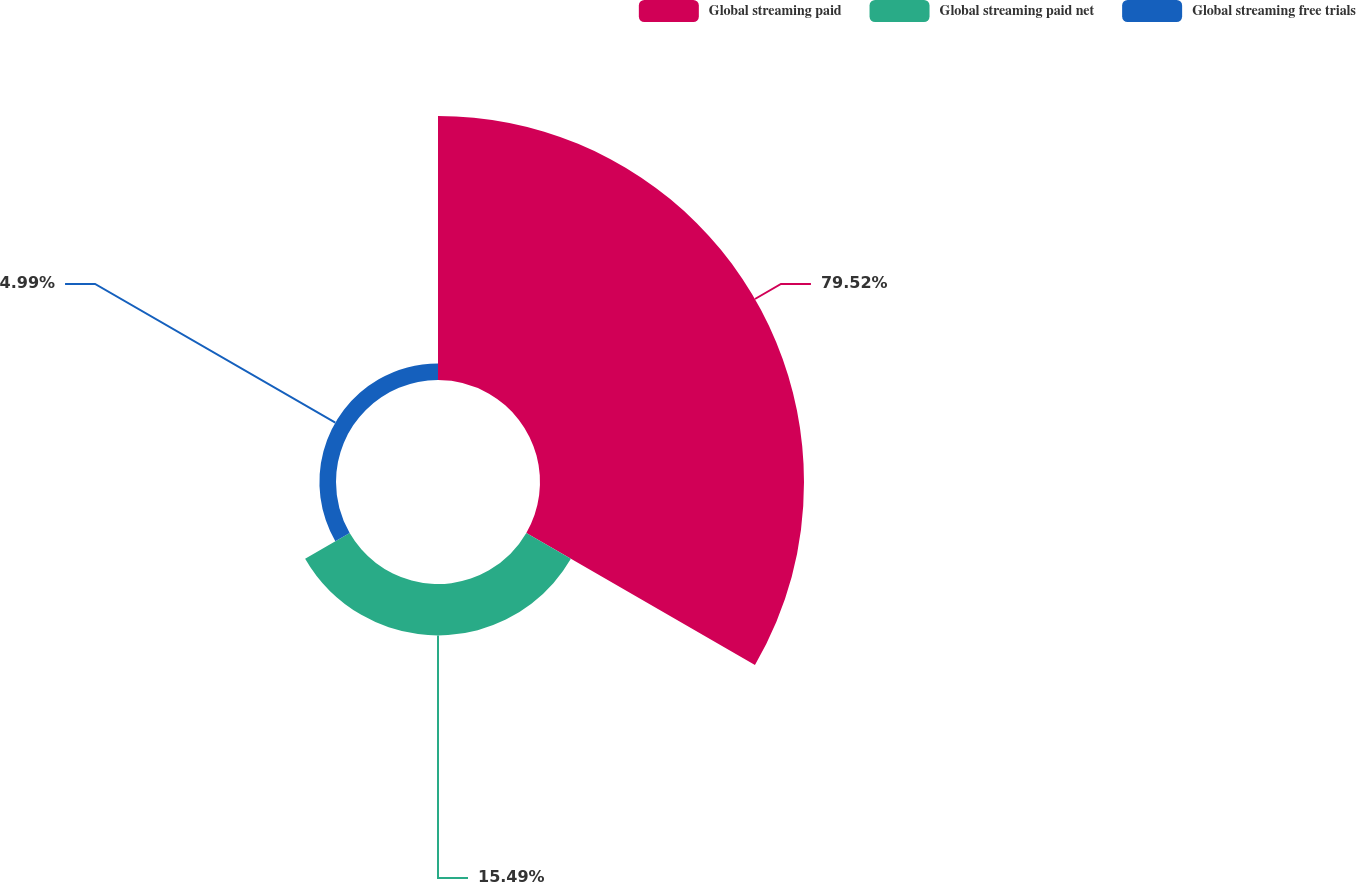Convert chart. <chart><loc_0><loc_0><loc_500><loc_500><pie_chart><fcel>Global streaming paid<fcel>Global streaming paid net<fcel>Global streaming free trials<nl><fcel>79.52%<fcel>15.49%<fcel>4.99%<nl></chart> 